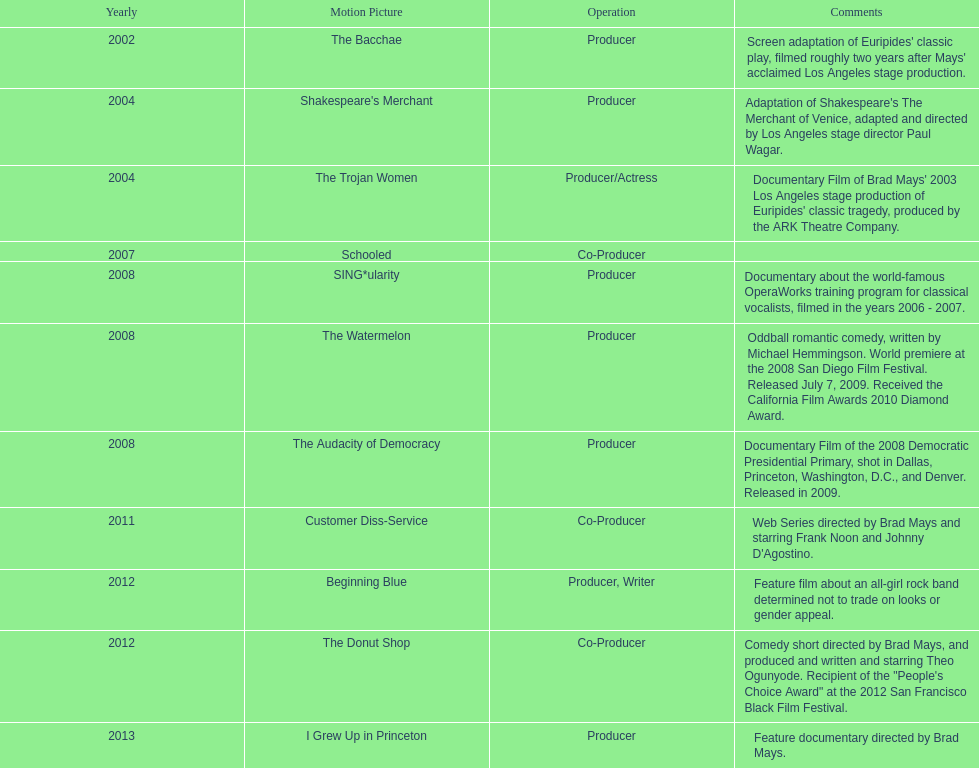Who was the first producer that made the film sing*ularity? Lorenda Starfelt. 